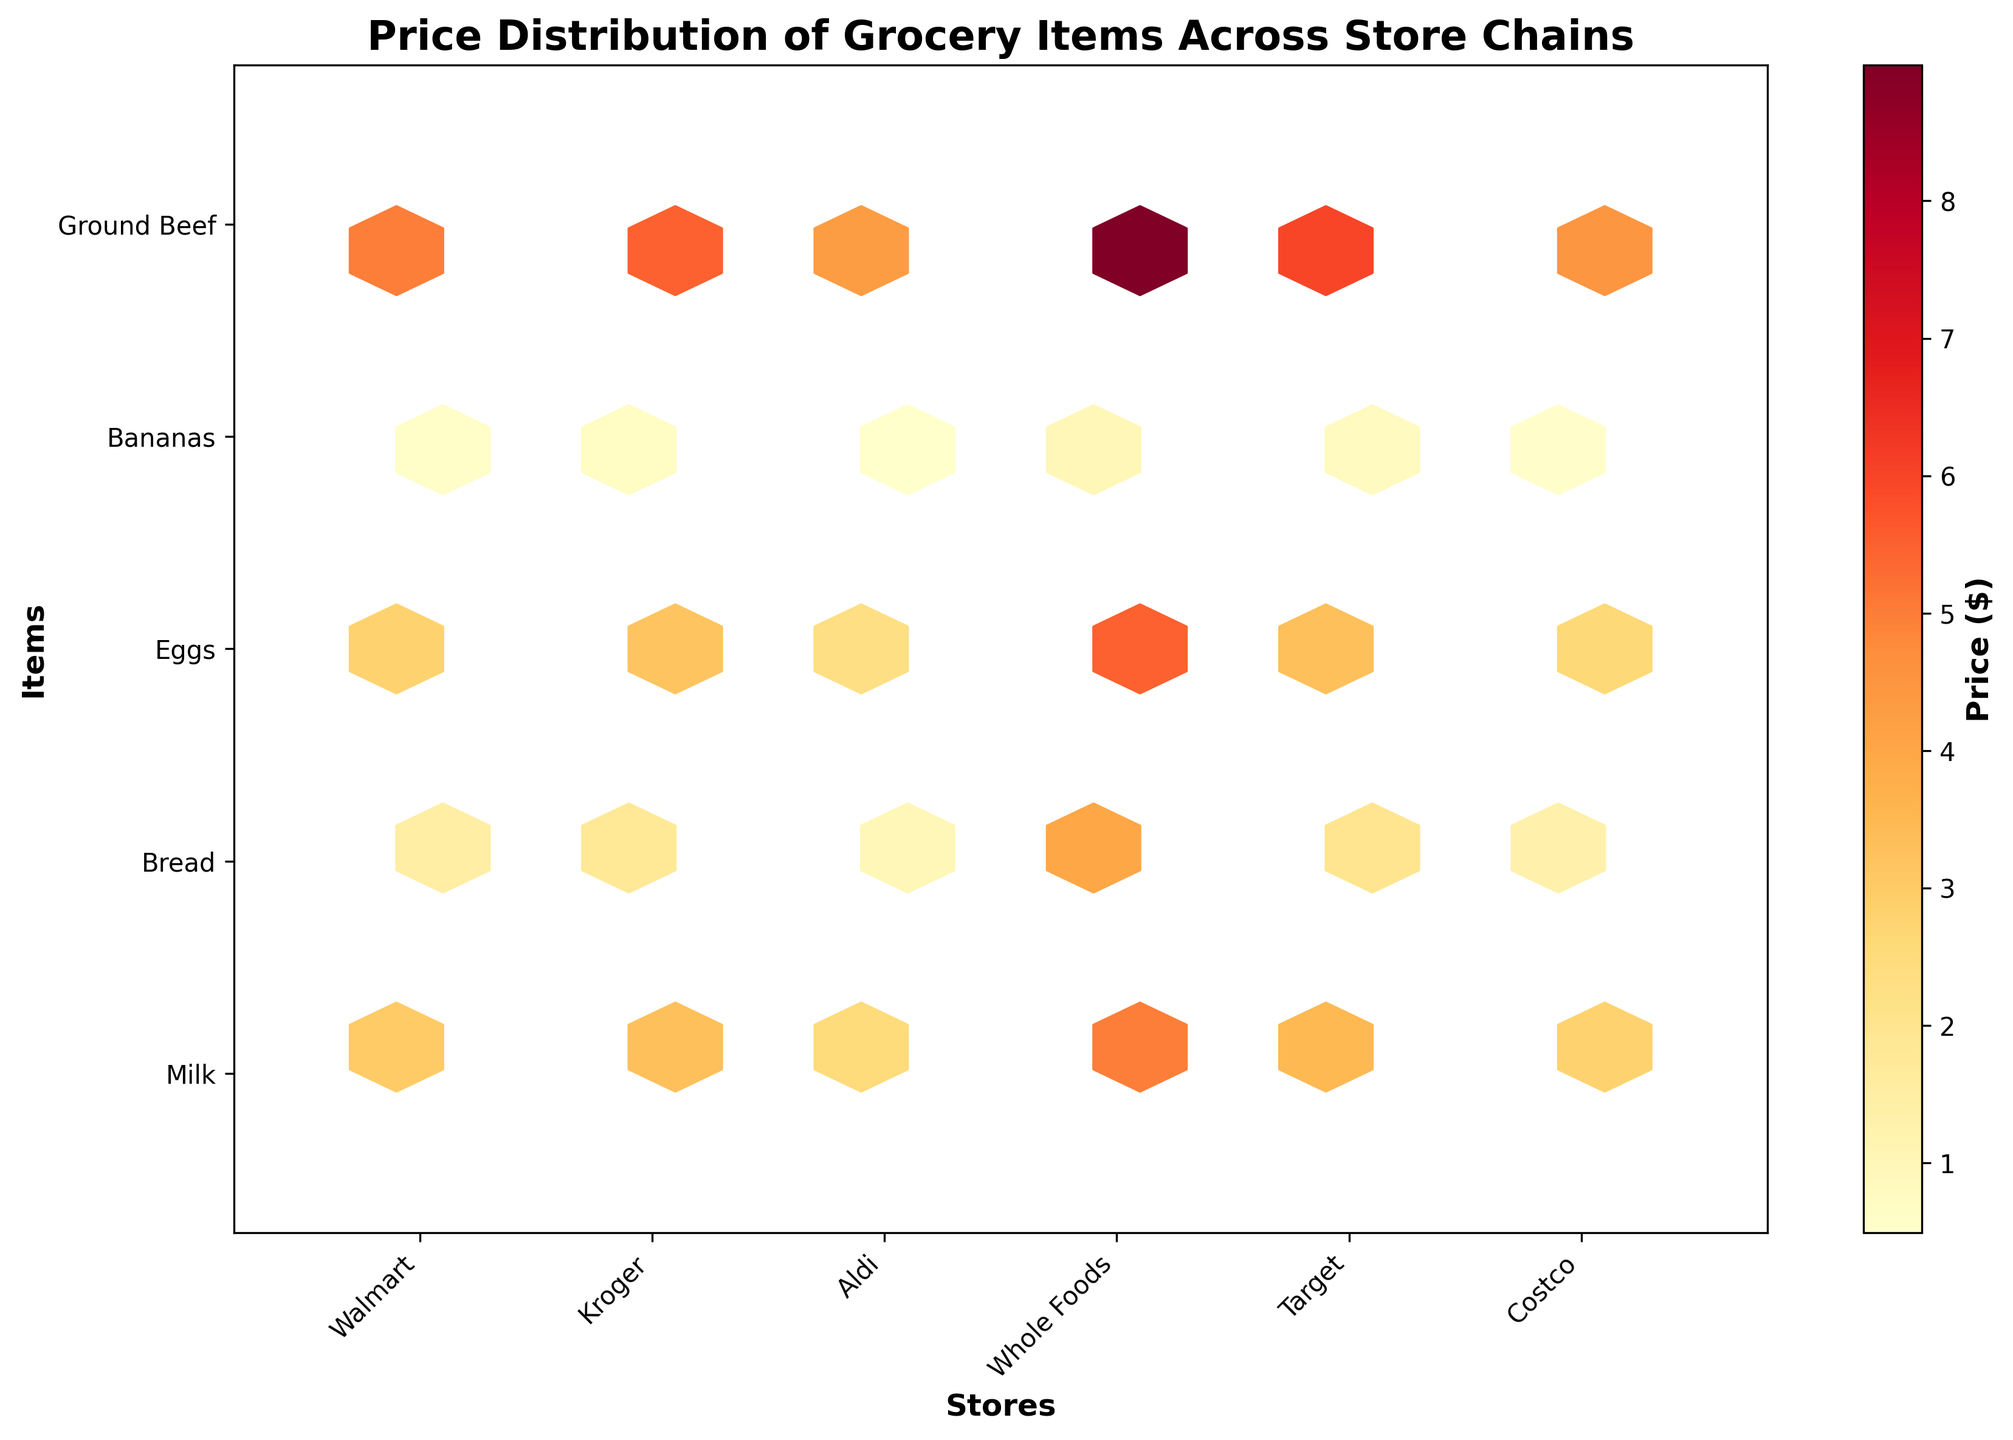What is the title of the figure? The title is usually located at the top of the figure. Here, it reads 'Price Distribution of Grocery Items Across Store Chains'.
Answer: Price Distribution of Grocery Items Across Store Chains How many store chains are compared in the figure? The x-axis of the figure represents different store chains. Counting the labels shows there are six store chains.
Answer: Six Which store chain has the highest price for ground beef? Look at the y-axis for 'Ground Beef' and scan along the x-axis for each store chain. The color intensity (dark color) at the 'Ground Beef' row indicates the highest price. Whole Foods has the darkest color.
Answer: Whole Foods How does the price of milk at Walmart compare to that at Aldi? First, find 'Milk' on the y-axis and look at Walmart and Aldi on the x-axis. Compare the color intensity. Walmart's color is lighter than Aldi's, indicating a higher price at Aldi.
Answer: It's lower at Walmart Which item has the lowest price at Kroger? Find 'Kroger' on the x-axis and scan vertically along its column. The item with the lightest color represents the lowest price. Bananas have the lightest color.
Answer: Bananas What is the average price of bread across all stores? Look at all the color tones along the 'Bread' row for different stores. Aldi has the lightest tone, $0.99. Sum all bread prices ($1.49 at Walmart, $1.79 at Kroger, $0.99 at Aldi, $3.99 at Whole Foods, $1.99 at Target, $1.29 at Costco) and then divide by the number of stores.
Answer: ($1.49 + $1.79 + $0.99 + $3.99 + $1.99 + $1.29) / 6 = $11.54/6 = $1.92 Which store has the most consistent price range for all items? Find the hexagons for each store along the x-axis. Observe the color variations vertically. Aldi has a column with the least variation in color tones, indicating consistent pricing.
Answer: Aldi What is the price range for eggs across all stores? Look at the colors in the 'Eggs' row for different stores. Identify the lightest and the darkest colors and convert them to their corresponding prices. The lowest is $2.29 at Aldi, and the highest is $5.49 at Whole Foods.
Answer: $2.29 to $5.49 In which store is the price of bananas almost twice the price compared to another store? Check the 'Bananas' row for all stores and compare the color intensities. At Whole Foods, bananas are $0.99, which is almost twice their price at Aldi ($0.49).
Answer: Whole Foods How does Target's pricing compare to other stores for dairy items (Milk, Eggs)? Compare the 'Milk' and 'Eggs' rows horizontally across all stores. Target's colors are in the mid-range (not the highest or lowest).
Answer: Higher than Aldi, Kroger, but lower than Whole Foods 